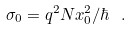Convert formula to latex. <formula><loc_0><loc_0><loc_500><loc_500>\sigma _ { 0 } = q ^ { 2 } N x _ { 0 } ^ { 2 } / \hbar { \ } .</formula> 